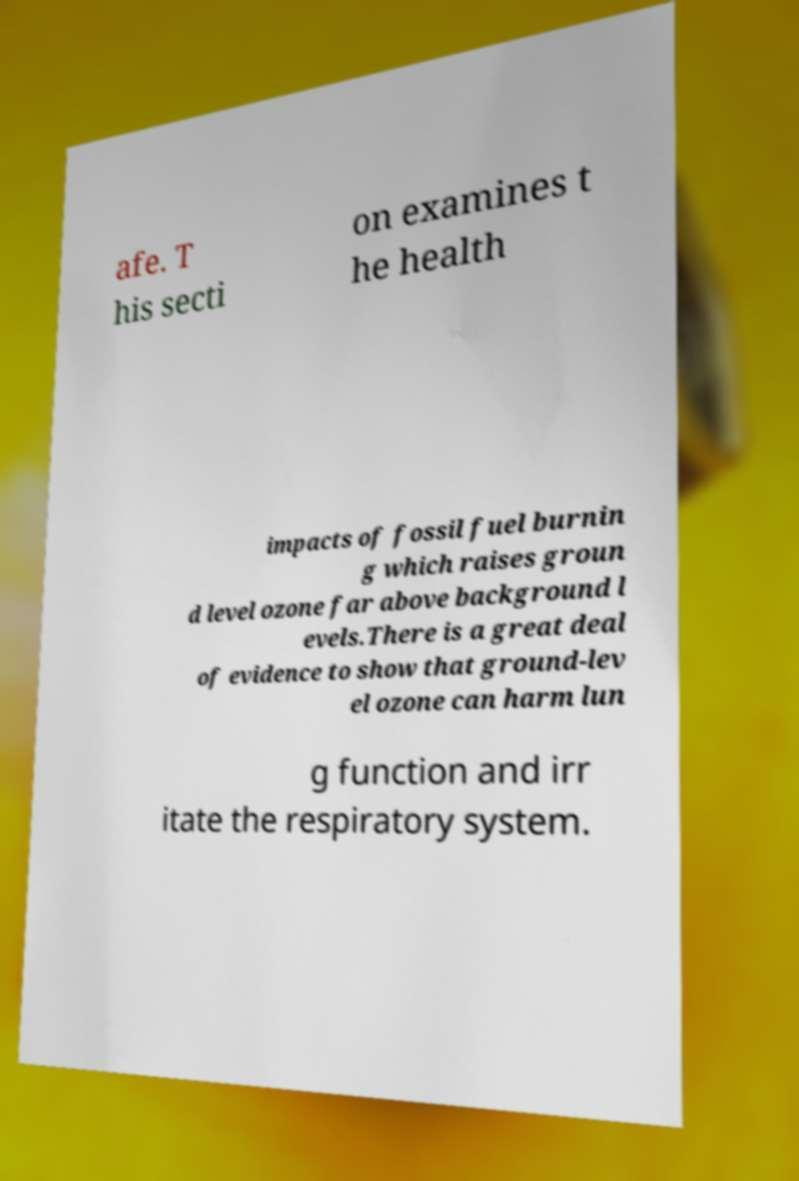There's text embedded in this image that I need extracted. Can you transcribe it verbatim? afe. T his secti on examines t he health impacts of fossil fuel burnin g which raises groun d level ozone far above background l evels.There is a great deal of evidence to show that ground-lev el ozone can harm lun g function and irr itate the respiratory system. 